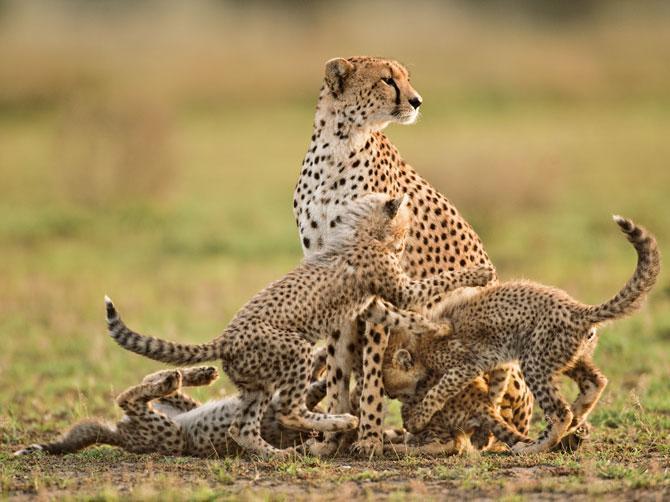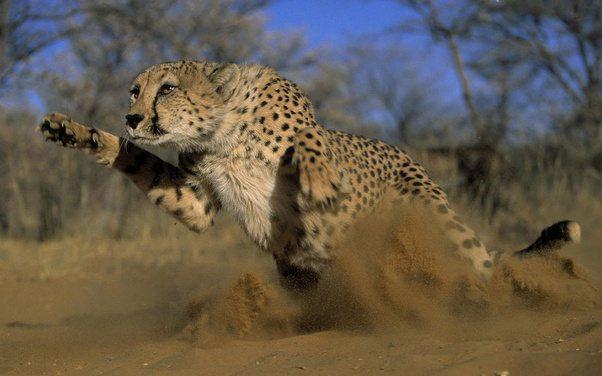The first image is the image on the left, the second image is the image on the right. Analyze the images presented: Is the assertion "An image shows one running cheetah with front paws off the ground." valid? Answer yes or no. Yes. 